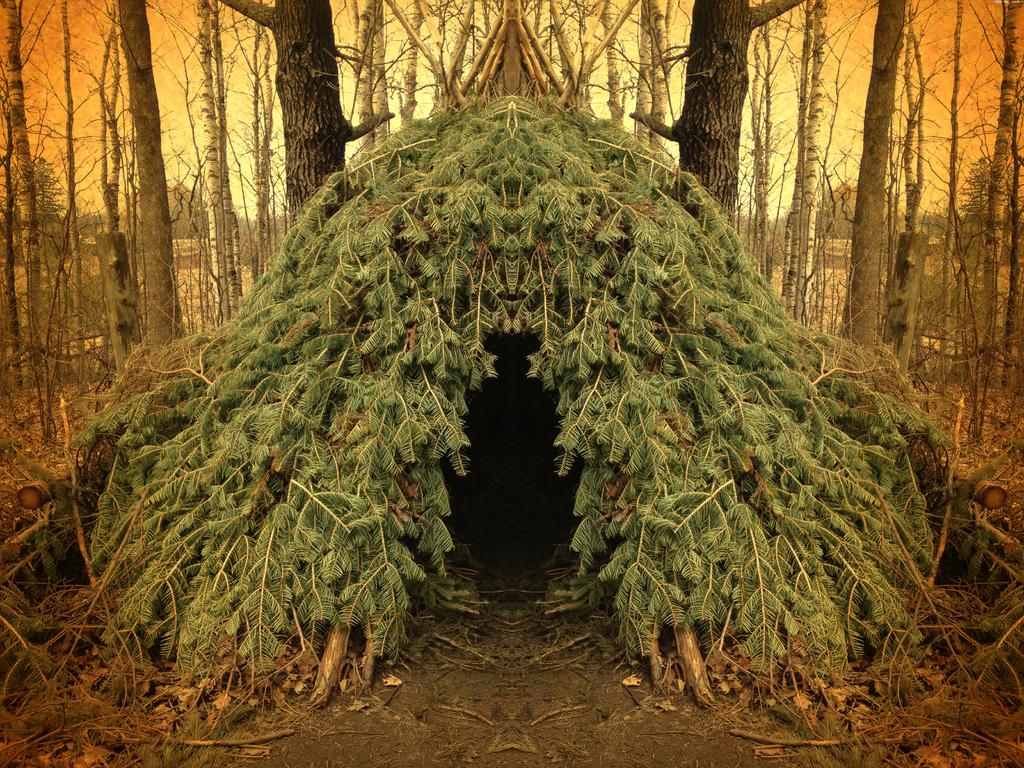What type of structure is present in the image? There is a hut in the image. What materials were used to build the hut? The hut is made of branches and leaves. What can be seen in the background of the image? There are trees and the sky visible in the background of the image. What things are being shown in the image? The image primarily shows a hut made of branches and leaves, with trees and the sky visible in the background. However, there are no specific "things" being shown in the image, as it is a scene rather than a collection of objects. 